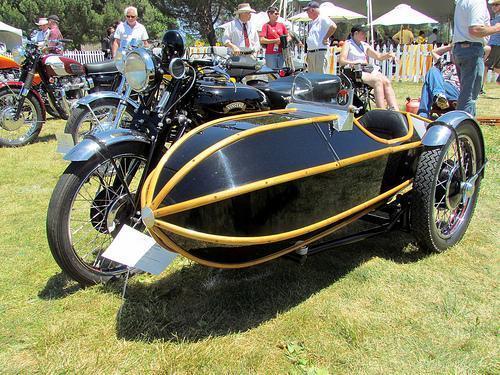How many motorcycles are in the picture?
Give a very brief answer. 3. 